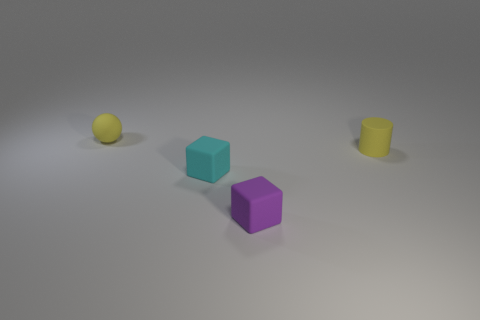The tiny matte object that is the same color as the rubber sphere is what shape?
Your answer should be very brief. Cylinder. What number of cylinders are either small purple rubber things or tiny matte things?
Provide a short and direct response. 1. Is the number of rubber objects on the right side of the purple thing the same as the number of tiny rubber cylinders that are in front of the yellow cylinder?
Ensure brevity in your answer.  No. The cyan object that is the same shape as the small purple thing is what size?
Make the answer very short. Small. There is a object that is both behind the cyan rubber cube and on the left side of the small matte cylinder; what size is it?
Make the answer very short. Small. Are there any purple matte cubes on the left side of the cyan matte cube?
Ensure brevity in your answer.  No. How many things are either rubber objects on the left side of the matte cylinder or tiny gray metallic things?
Give a very brief answer. 3. What number of matte balls are in front of the tiny block behind the purple cube?
Make the answer very short. 0. Are there fewer matte objects to the left of the small yellow matte ball than small rubber blocks that are behind the purple rubber block?
Offer a very short reply. Yes. There is a tiny yellow rubber thing to the right of the tiny rubber sphere on the left side of the purple block; what is its shape?
Your answer should be very brief. Cylinder. 